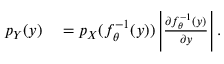Convert formula to latex. <formula><loc_0><loc_0><loc_500><loc_500>\begin{array} { r l } { p _ { Y } ( y ) } & = p _ { X } ( f _ { \theta } ^ { - 1 } ( y ) ) \left | \frac { \partial f _ { \theta } ^ { - 1 } ( y ) } { \partial y } \right | . } \end{array}</formula> 